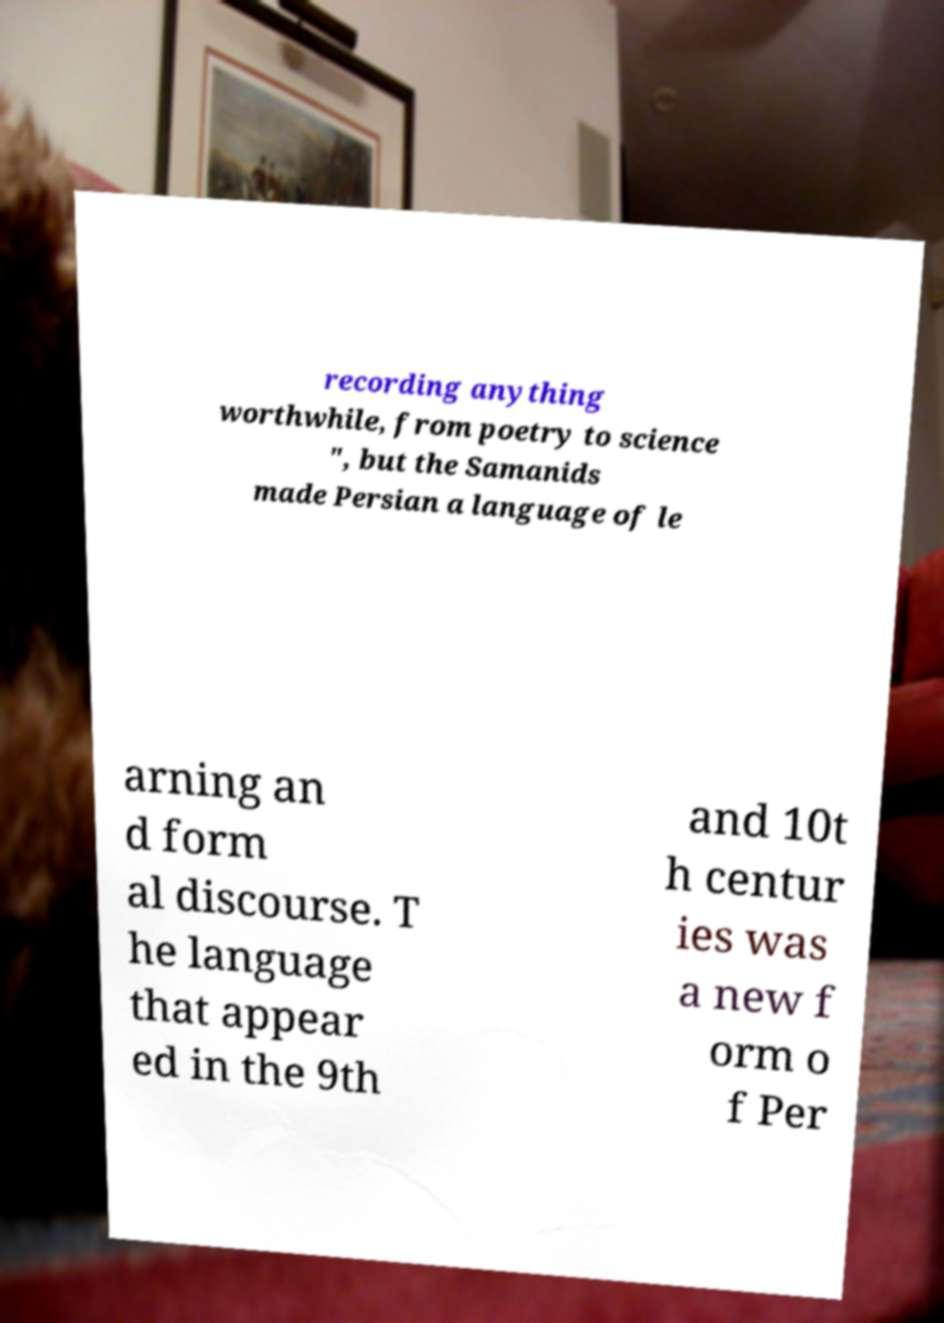Can you accurately transcribe the text from the provided image for me? recording anything worthwhile, from poetry to science ", but the Samanids made Persian a language of le arning an d form al discourse. T he language that appear ed in the 9th and 10t h centur ies was a new f orm o f Per 